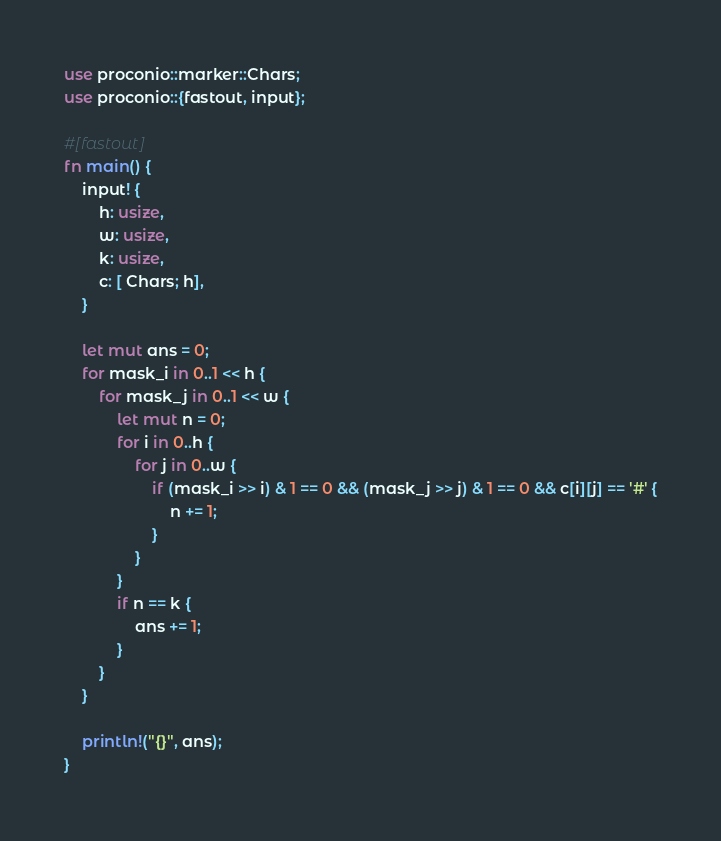Convert code to text. <code><loc_0><loc_0><loc_500><loc_500><_Rust_>use proconio::marker::Chars;
use proconio::{fastout, input};

#[fastout]
fn main() {
    input! {
        h: usize,
        w: usize,
        k: usize,
        c: [ Chars; h],
    }

    let mut ans = 0;
    for mask_i in 0..1 << h {
        for mask_j in 0..1 << w {
            let mut n = 0;
            for i in 0..h {
                for j in 0..w {
                    if (mask_i >> i) & 1 == 0 && (mask_j >> j) & 1 == 0 && c[i][j] == '#' {
                        n += 1;
                    }
                }
            }
            if n == k {
                ans += 1;
            }
        }
    }

    println!("{}", ans);
}
</code> 